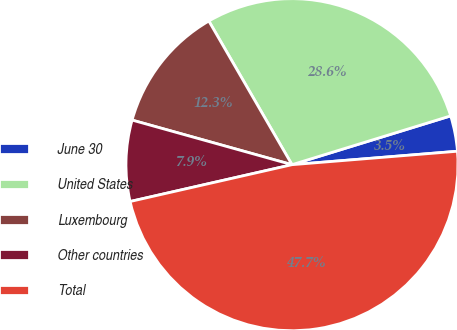Convert chart. <chart><loc_0><loc_0><loc_500><loc_500><pie_chart><fcel>June 30<fcel>United States<fcel>Luxembourg<fcel>Other countries<fcel>Total<nl><fcel>3.46%<fcel>28.6%<fcel>12.32%<fcel>7.89%<fcel>47.73%<nl></chart> 